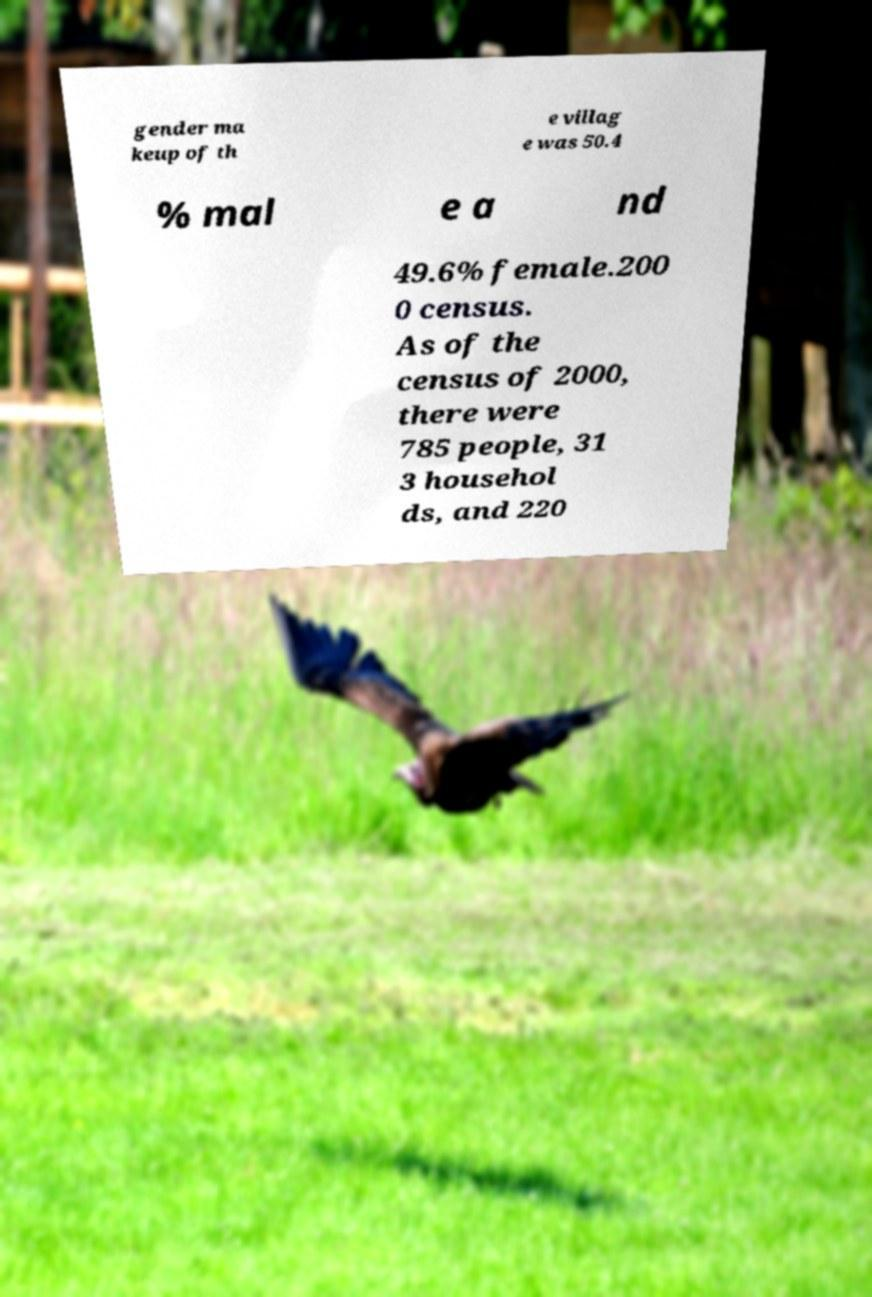For documentation purposes, I need the text within this image transcribed. Could you provide that? gender ma keup of th e villag e was 50.4 % mal e a nd 49.6% female.200 0 census. As of the census of 2000, there were 785 people, 31 3 househol ds, and 220 